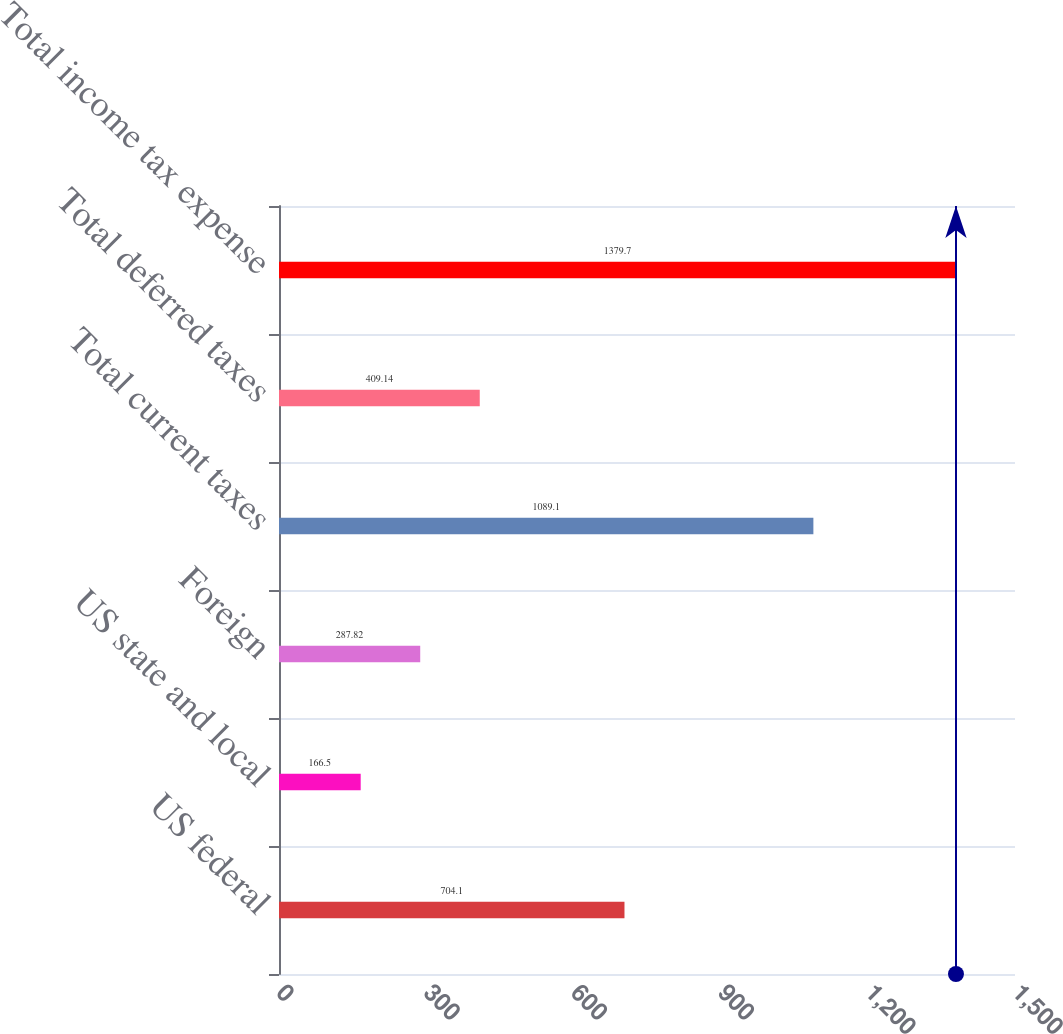<chart> <loc_0><loc_0><loc_500><loc_500><bar_chart><fcel>US federal<fcel>US state and local<fcel>Foreign<fcel>Total current taxes<fcel>Total deferred taxes<fcel>Total income tax expense<nl><fcel>704.1<fcel>166.5<fcel>287.82<fcel>1089.1<fcel>409.14<fcel>1379.7<nl></chart> 